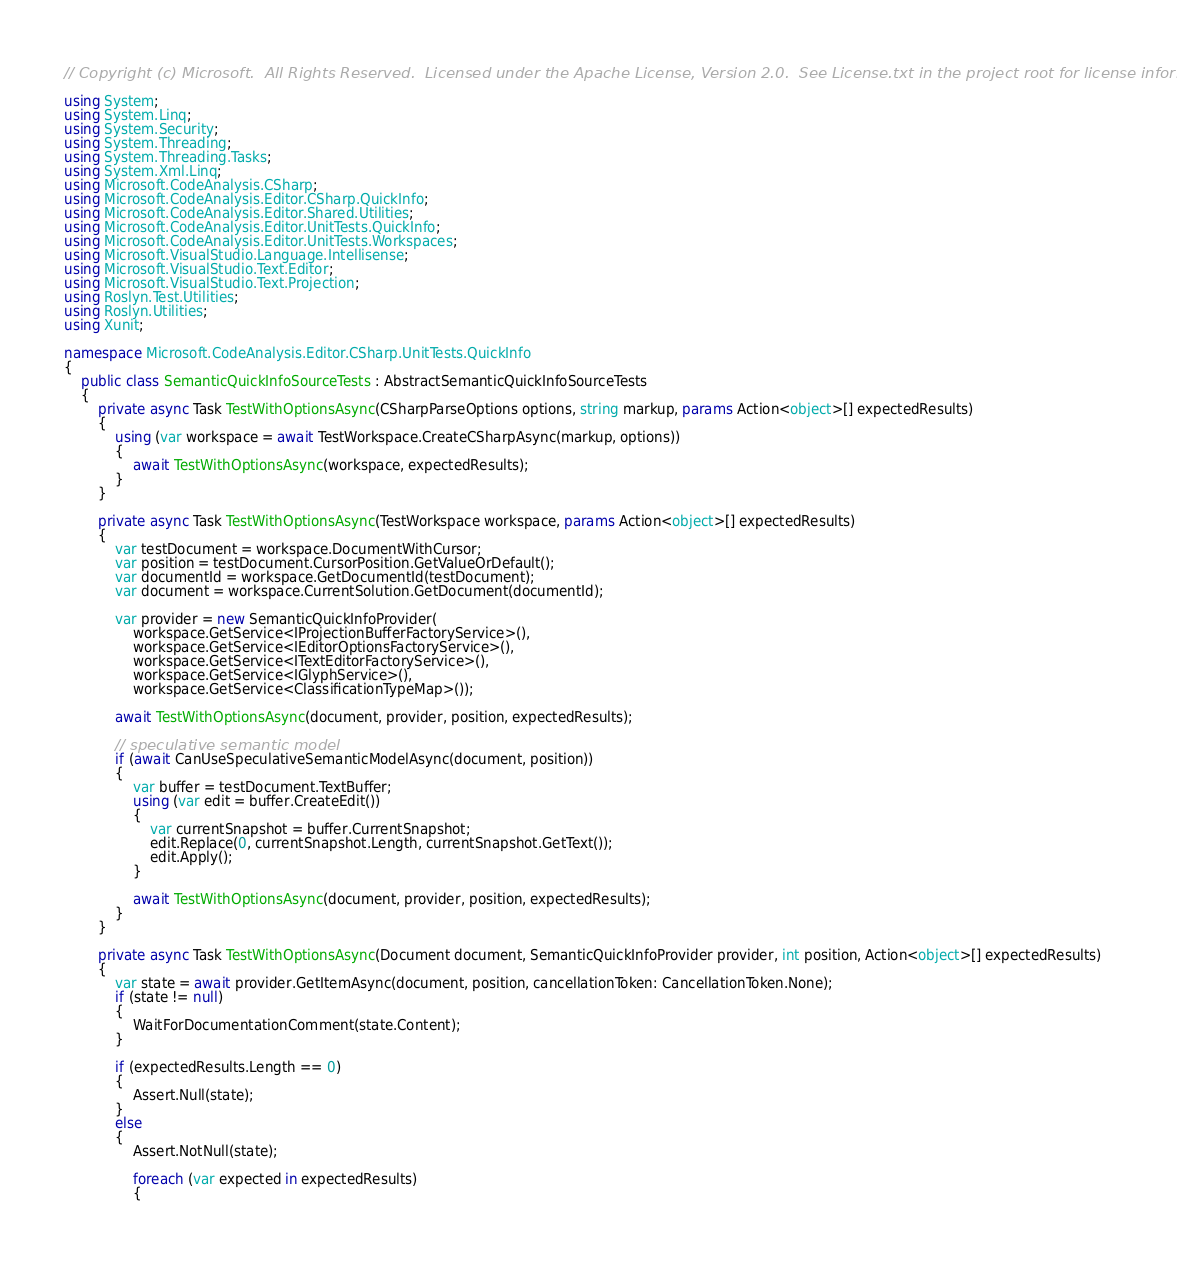<code> <loc_0><loc_0><loc_500><loc_500><_C#_>// Copyright (c) Microsoft.  All Rights Reserved.  Licensed under the Apache License, Version 2.0.  See License.txt in the project root for license information.

using System;
using System.Linq;
using System.Security;
using System.Threading;
using System.Threading.Tasks;
using System.Xml.Linq;
using Microsoft.CodeAnalysis.CSharp;
using Microsoft.CodeAnalysis.Editor.CSharp.QuickInfo;
using Microsoft.CodeAnalysis.Editor.Shared.Utilities;
using Microsoft.CodeAnalysis.Editor.UnitTests.QuickInfo;
using Microsoft.CodeAnalysis.Editor.UnitTests.Workspaces;
using Microsoft.VisualStudio.Language.Intellisense;
using Microsoft.VisualStudio.Text.Editor;
using Microsoft.VisualStudio.Text.Projection;
using Roslyn.Test.Utilities;
using Roslyn.Utilities;
using Xunit;

namespace Microsoft.CodeAnalysis.Editor.CSharp.UnitTests.QuickInfo
{
    public class SemanticQuickInfoSourceTests : AbstractSemanticQuickInfoSourceTests
    {
        private async Task TestWithOptionsAsync(CSharpParseOptions options, string markup, params Action<object>[] expectedResults)
        {
            using (var workspace = await TestWorkspace.CreateCSharpAsync(markup, options))
            {
                await TestWithOptionsAsync(workspace, expectedResults);
            }
        }

        private async Task TestWithOptionsAsync(TestWorkspace workspace, params Action<object>[] expectedResults)
        {
            var testDocument = workspace.DocumentWithCursor;
            var position = testDocument.CursorPosition.GetValueOrDefault();
            var documentId = workspace.GetDocumentId(testDocument);
            var document = workspace.CurrentSolution.GetDocument(documentId);

            var provider = new SemanticQuickInfoProvider(
                workspace.GetService<IProjectionBufferFactoryService>(),
                workspace.GetService<IEditorOptionsFactoryService>(),
                workspace.GetService<ITextEditorFactoryService>(),
                workspace.GetService<IGlyphService>(),
                workspace.GetService<ClassificationTypeMap>());

            await TestWithOptionsAsync(document, provider, position, expectedResults);

            // speculative semantic model
            if (await CanUseSpeculativeSemanticModelAsync(document, position))
            {
                var buffer = testDocument.TextBuffer;
                using (var edit = buffer.CreateEdit())
                {
                    var currentSnapshot = buffer.CurrentSnapshot;
                    edit.Replace(0, currentSnapshot.Length, currentSnapshot.GetText());
                    edit.Apply();
                }

                await TestWithOptionsAsync(document, provider, position, expectedResults);
            }
        }

        private async Task TestWithOptionsAsync(Document document, SemanticQuickInfoProvider provider, int position, Action<object>[] expectedResults)
        {
            var state = await provider.GetItemAsync(document, position, cancellationToken: CancellationToken.None);
            if (state != null)
            {
                WaitForDocumentationComment(state.Content);
            }

            if (expectedResults.Length == 0)
            {
                Assert.Null(state);
            }
            else
            {
                Assert.NotNull(state);

                foreach (var expected in expectedResults)
                {</code> 